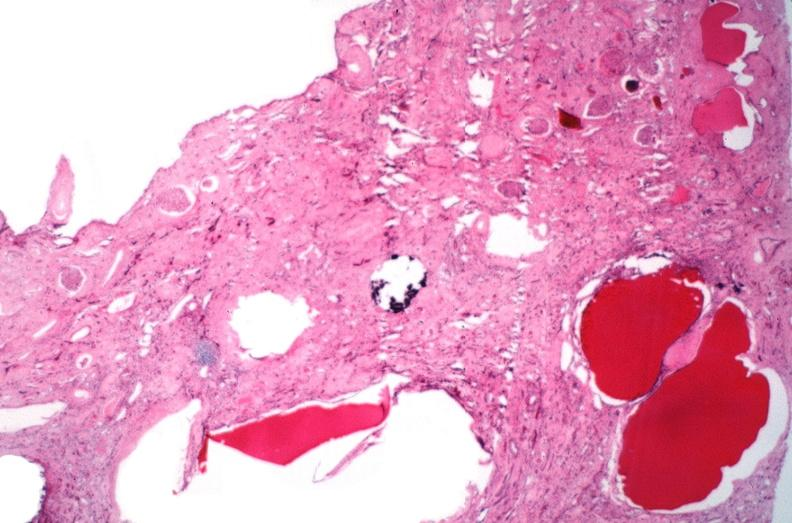what does this image show?
Answer the question using a single word or phrase. Kidney 